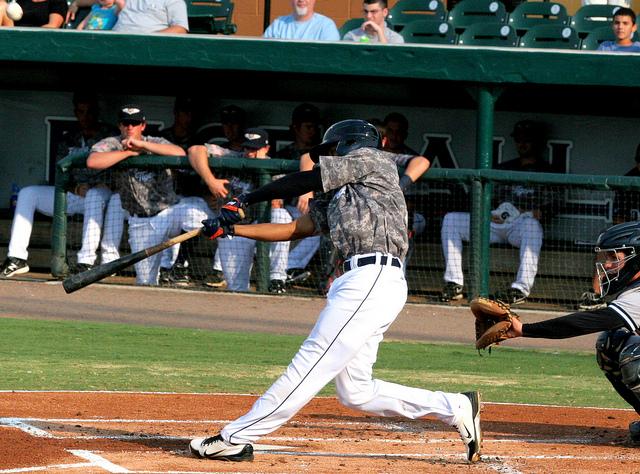What is the primary color of the batter's pants?
Quick response, please. White. Is this a professional game?
Keep it brief. Yes. What is the sport?
Quick response, please. Baseball. What's on the batter's head?
Quick response, please. Helmet. 